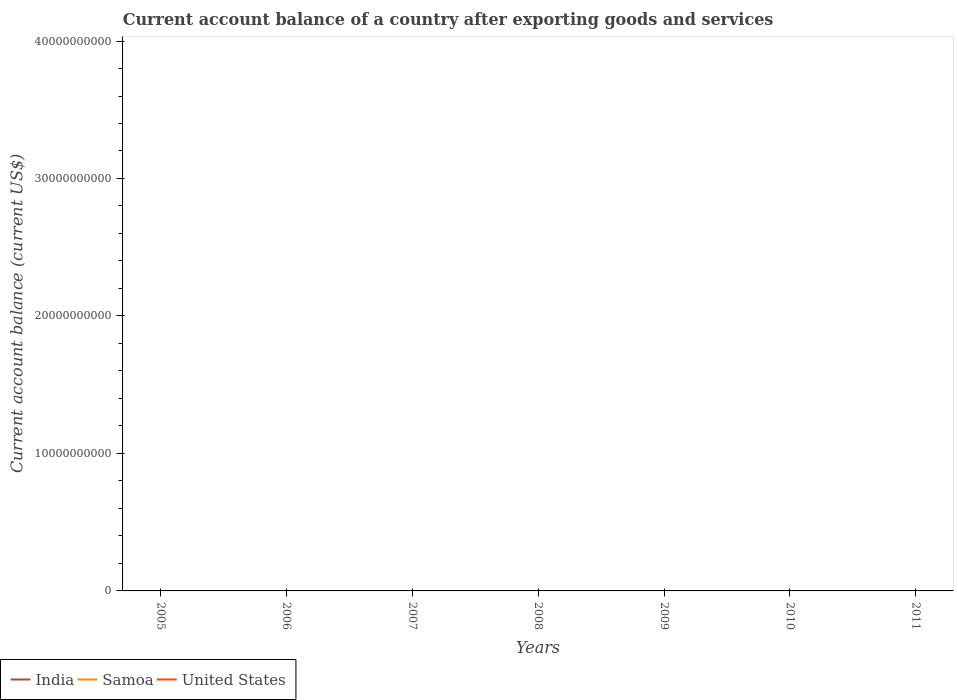Does the line corresponding to India intersect with the line corresponding to United States?
Give a very brief answer. No. Across all years, what is the maximum account balance in United States?
Your answer should be compact. 0. What is the difference between the highest and the lowest account balance in United States?
Make the answer very short. 0. Are the values on the major ticks of Y-axis written in scientific E-notation?
Ensure brevity in your answer.  No. Does the graph contain grids?
Offer a terse response. No. How are the legend labels stacked?
Provide a short and direct response. Horizontal. What is the title of the graph?
Give a very brief answer. Current account balance of a country after exporting goods and services. What is the label or title of the X-axis?
Provide a succinct answer. Years. What is the label or title of the Y-axis?
Give a very brief answer. Current account balance (current US$). What is the Current account balance (current US$) of United States in 2005?
Provide a succinct answer. 0. What is the Current account balance (current US$) in India in 2006?
Make the answer very short. 0. What is the Current account balance (current US$) of Samoa in 2006?
Your answer should be very brief. 0. What is the Current account balance (current US$) in India in 2007?
Provide a succinct answer. 0. What is the Current account balance (current US$) in India in 2008?
Keep it short and to the point. 0. What is the Current account balance (current US$) of Samoa in 2008?
Your answer should be very brief. 0. What is the Current account balance (current US$) in Samoa in 2009?
Your answer should be very brief. 0. What is the Current account balance (current US$) of United States in 2009?
Give a very brief answer. 0. What is the Current account balance (current US$) of India in 2010?
Keep it short and to the point. 0. What is the Current account balance (current US$) in United States in 2010?
Offer a very short reply. 0. What is the total Current account balance (current US$) in India in the graph?
Offer a terse response. 0. What is the total Current account balance (current US$) of Samoa in the graph?
Your answer should be very brief. 0. What is the average Current account balance (current US$) in India per year?
Offer a very short reply. 0. 